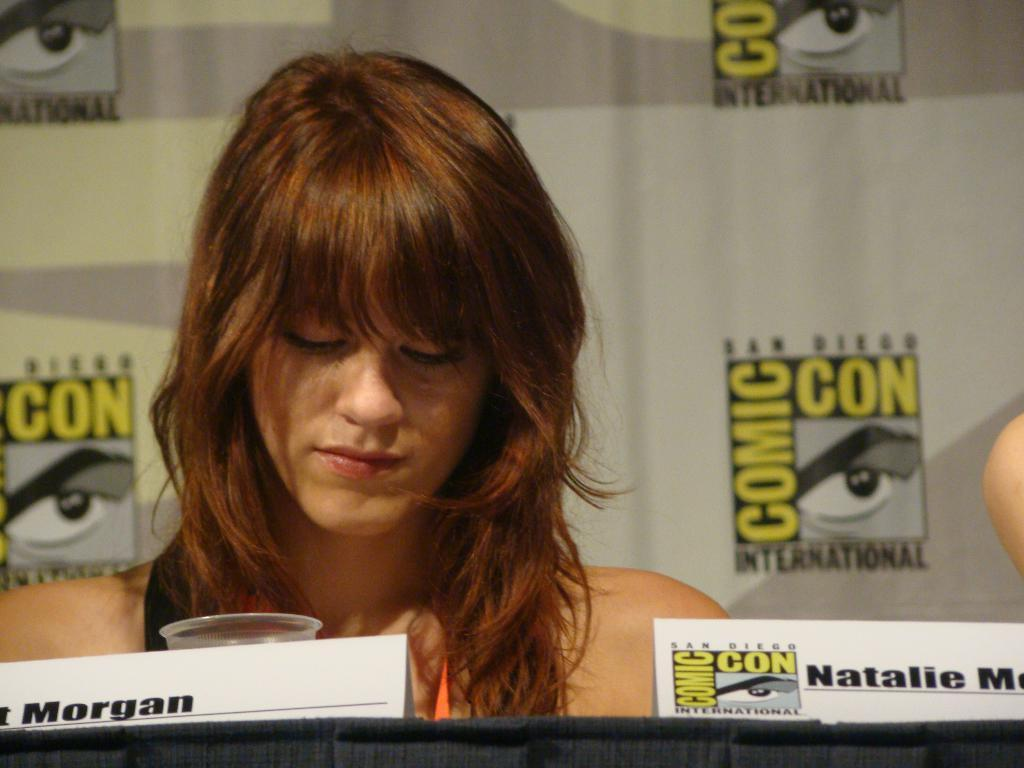Who is present in the image? There is a woman in the image. What is in front of the woman? There is a glass and a board in front of the woman. What can be seen in the background of the image? There are logos and text visible in the background of the image. How many kittens are playing with the screw in the image? There are no kittens or screws present in the image. 